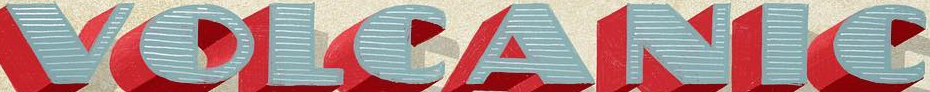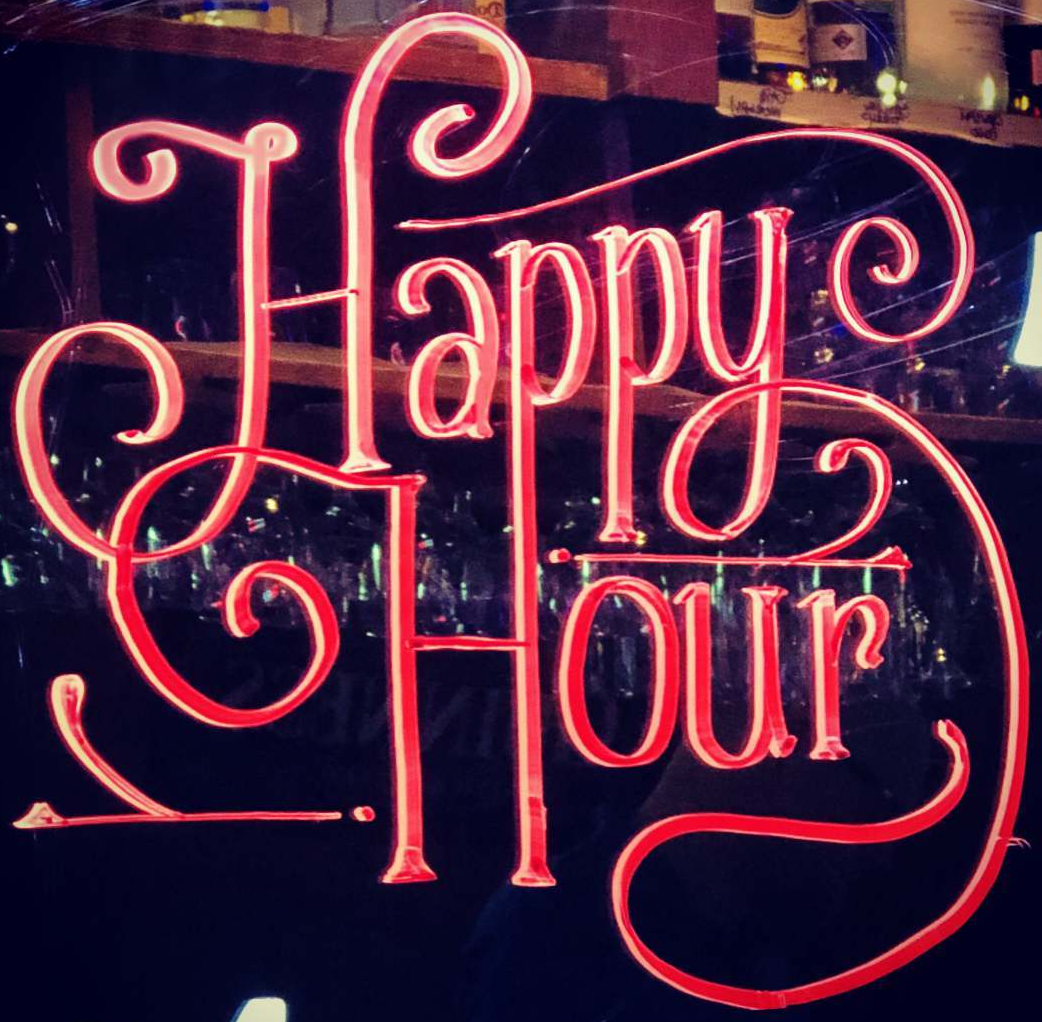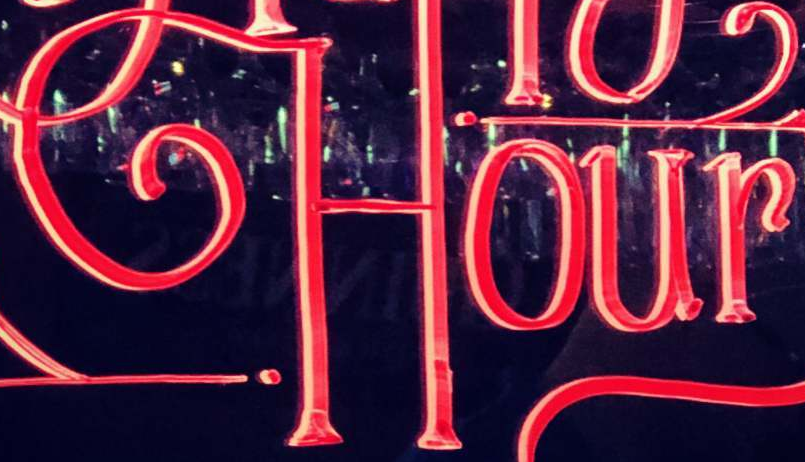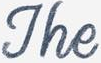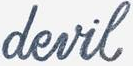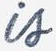Read the text content from these images in order, separated by a semicolon. VOLCANIC; Happy; Hour; The; devil; is 